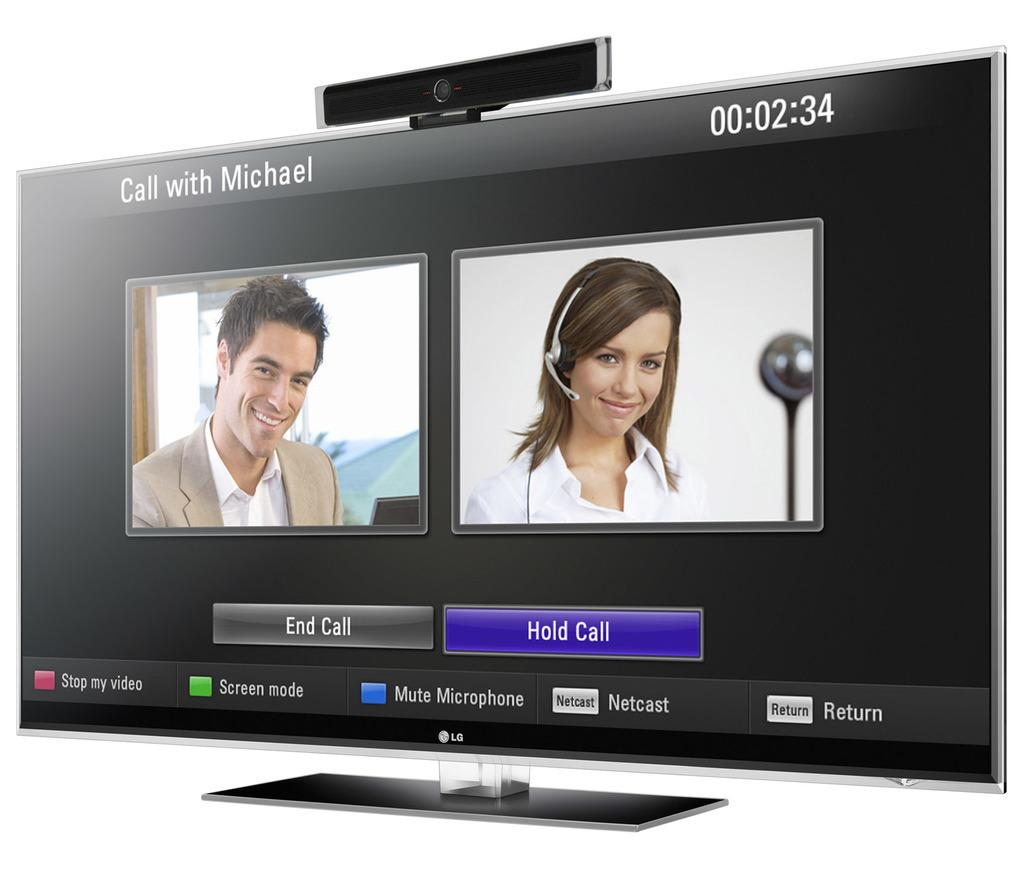Provide a one-sentence caption for the provided image. LG computer screen that shows a man on the left and woman on the right. 